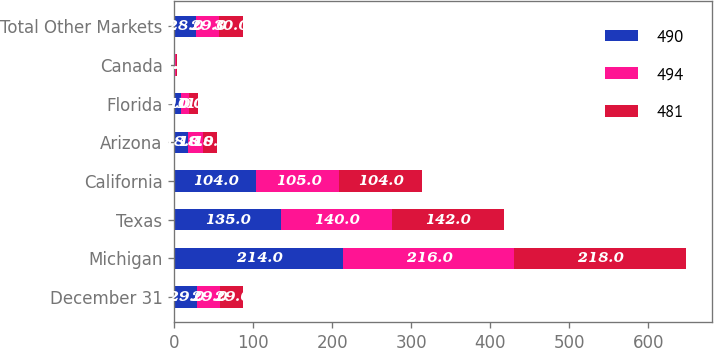<chart> <loc_0><loc_0><loc_500><loc_500><stacked_bar_chart><ecel><fcel>December 31<fcel>Michigan<fcel>Texas<fcel>California<fcel>Arizona<fcel>Florida<fcel>Canada<fcel>Total Other Markets<nl><fcel>490<fcel>29<fcel>214<fcel>135<fcel>104<fcel>18<fcel>9<fcel>1<fcel>28<nl><fcel>494<fcel>29<fcel>216<fcel>140<fcel>105<fcel>18<fcel>10<fcel>1<fcel>29<nl><fcel>481<fcel>29<fcel>218<fcel>142<fcel>104<fcel>18<fcel>11<fcel>1<fcel>30<nl></chart> 